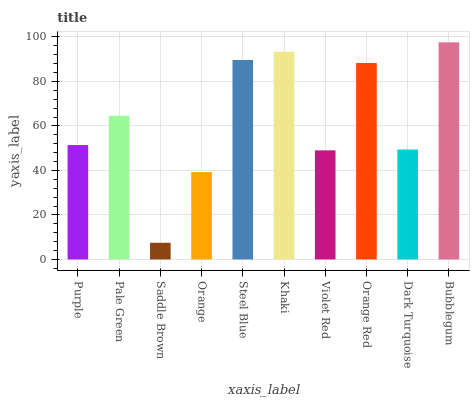Is Pale Green the minimum?
Answer yes or no. No. Is Pale Green the maximum?
Answer yes or no. No. Is Pale Green greater than Purple?
Answer yes or no. Yes. Is Purple less than Pale Green?
Answer yes or no. Yes. Is Purple greater than Pale Green?
Answer yes or no. No. Is Pale Green less than Purple?
Answer yes or no. No. Is Pale Green the high median?
Answer yes or no. Yes. Is Purple the low median?
Answer yes or no. Yes. Is Steel Blue the high median?
Answer yes or no. No. Is Dark Turquoise the low median?
Answer yes or no. No. 